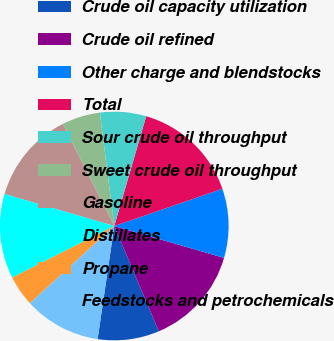<chart> <loc_0><loc_0><loc_500><loc_500><pie_chart><fcel>Crude oil capacity utilization<fcel>Crude oil refined<fcel>Other charge and blendstocks<fcel>Total<fcel>Sour crude oil throughput<fcel>Sweet crude oil throughput<fcel>Gasoline<fcel>Distillates<fcel>Propane<fcel>Feedstocks and petrochemicals<nl><fcel>8.7%<fcel>14.13%<fcel>9.78%<fcel>15.21%<fcel>6.52%<fcel>5.44%<fcel>13.04%<fcel>11.96%<fcel>4.35%<fcel>10.87%<nl></chart> 